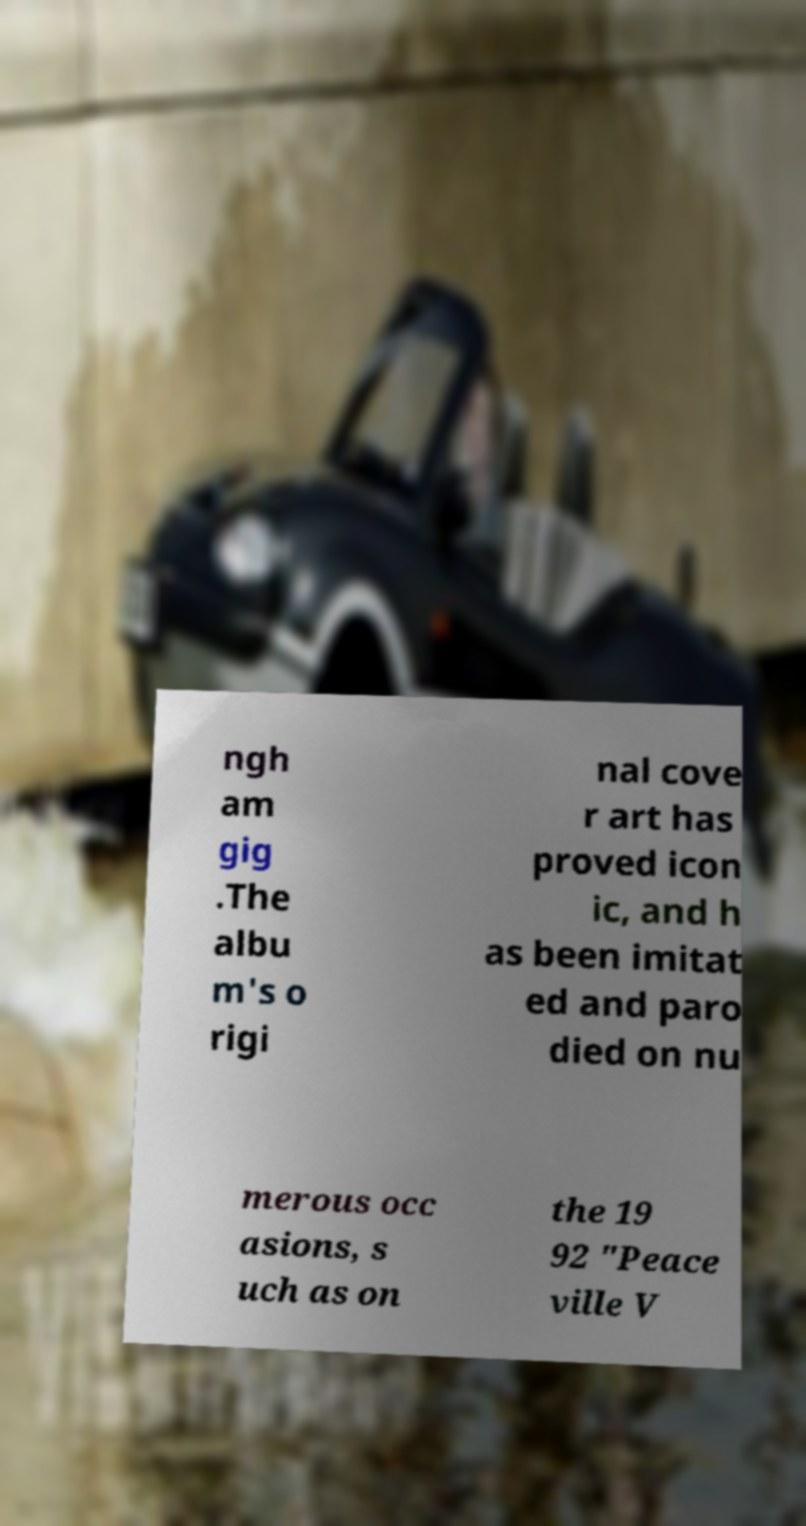Please identify and transcribe the text found in this image. ngh am gig .The albu m's o rigi nal cove r art has proved icon ic, and h as been imitat ed and paro died on nu merous occ asions, s uch as on the 19 92 "Peace ville V 